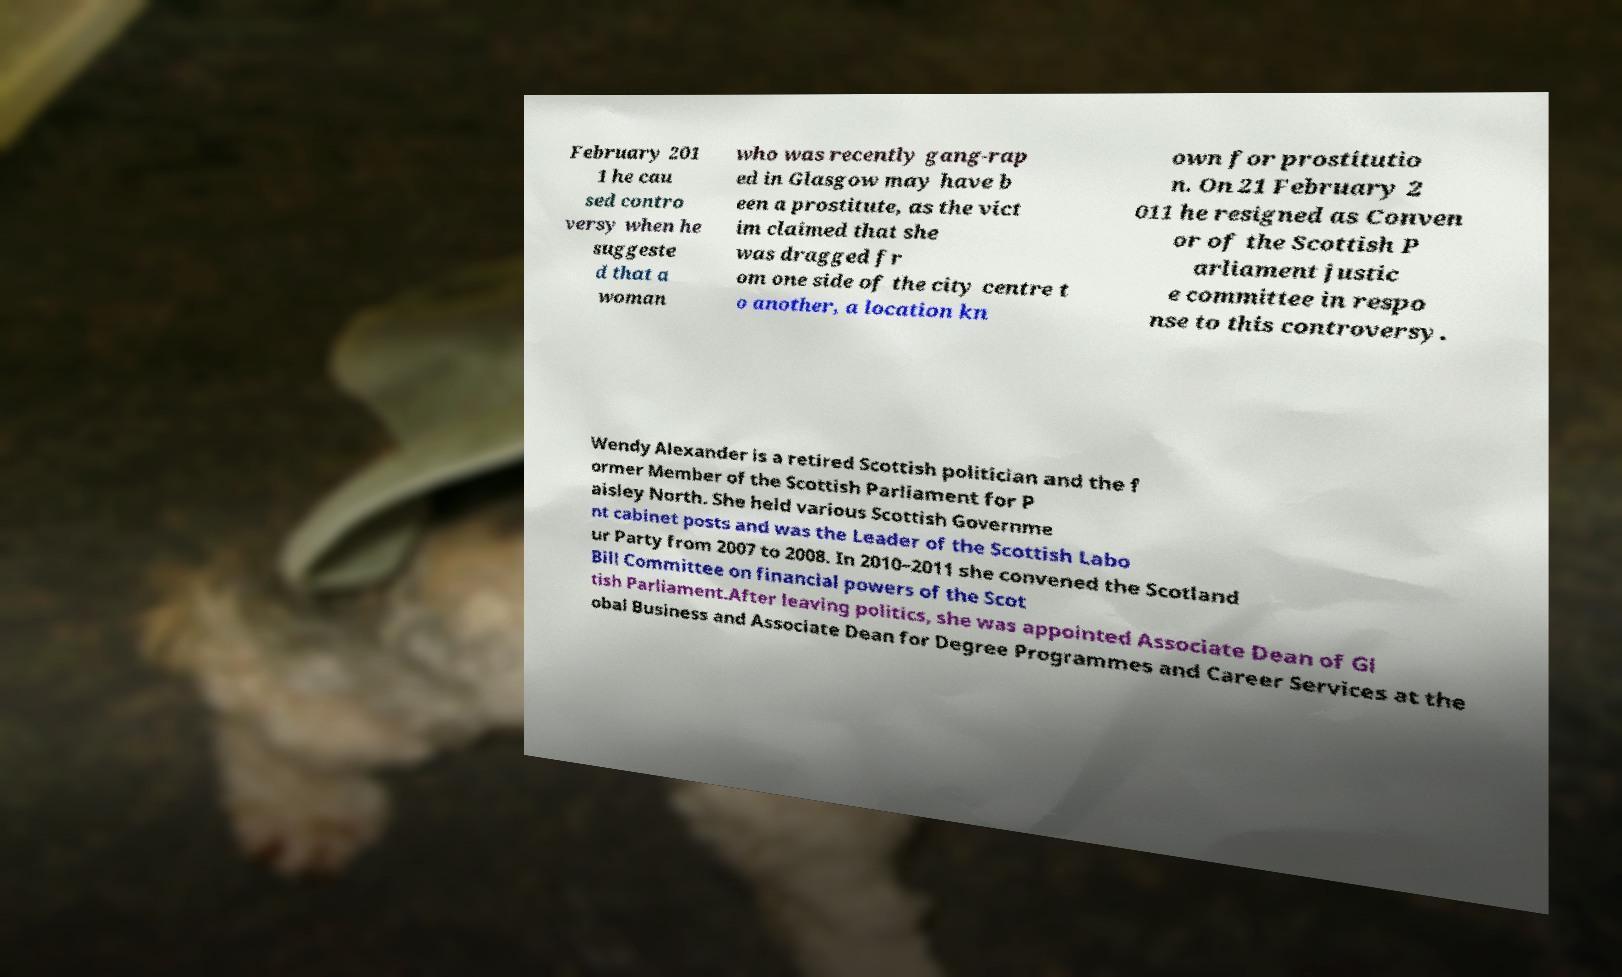Please identify and transcribe the text found in this image. February 201 1 he cau sed contro versy when he suggeste d that a woman who was recently gang-rap ed in Glasgow may have b een a prostitute, as the vict im claimed that she was dragged fr om one side of the city centre t o another, a location kn own for prostitutio n. On 21 February 2 011 he resigned as Conven or of the Scottish P arliament justic e committee in respo nse to this controversy. Wendy Alexander is a retired Scottish politician and the f ormer Member of the Scottish Parliament for P aisley North. She held various Scottish Governme nt cabinet posts and was the Leader of the Scottish Labo ur Party from 2007 to 2008. In 2010–2011 she convened the Scotland Bill Committee on financial powers of the Scot tish Parliament.After leaving politics, she was appointed Associate Dean of Gl obal Business and Associate Dean for Degree Programmes and Career Services at the 